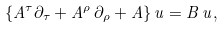<formula> <loc_0><loc_0><loc_500><loc_500>\{ A ^ { \tau } \partial _ { \tau } + A ^ { \rho } \, \partial _ { \rho } + A \} \, u = B \, u ,</formula> 